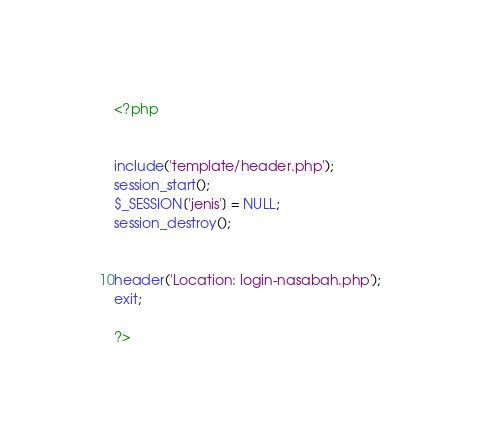<code> <loc_0><loc_0><loc_500><loc_500><_PHP_><?php 


include('template/header.php');
session_start();
$_SESSION['jenis'] = NULL;
session_destroy();


header('Location: login-nasabah.php');
exit;

?></code> 